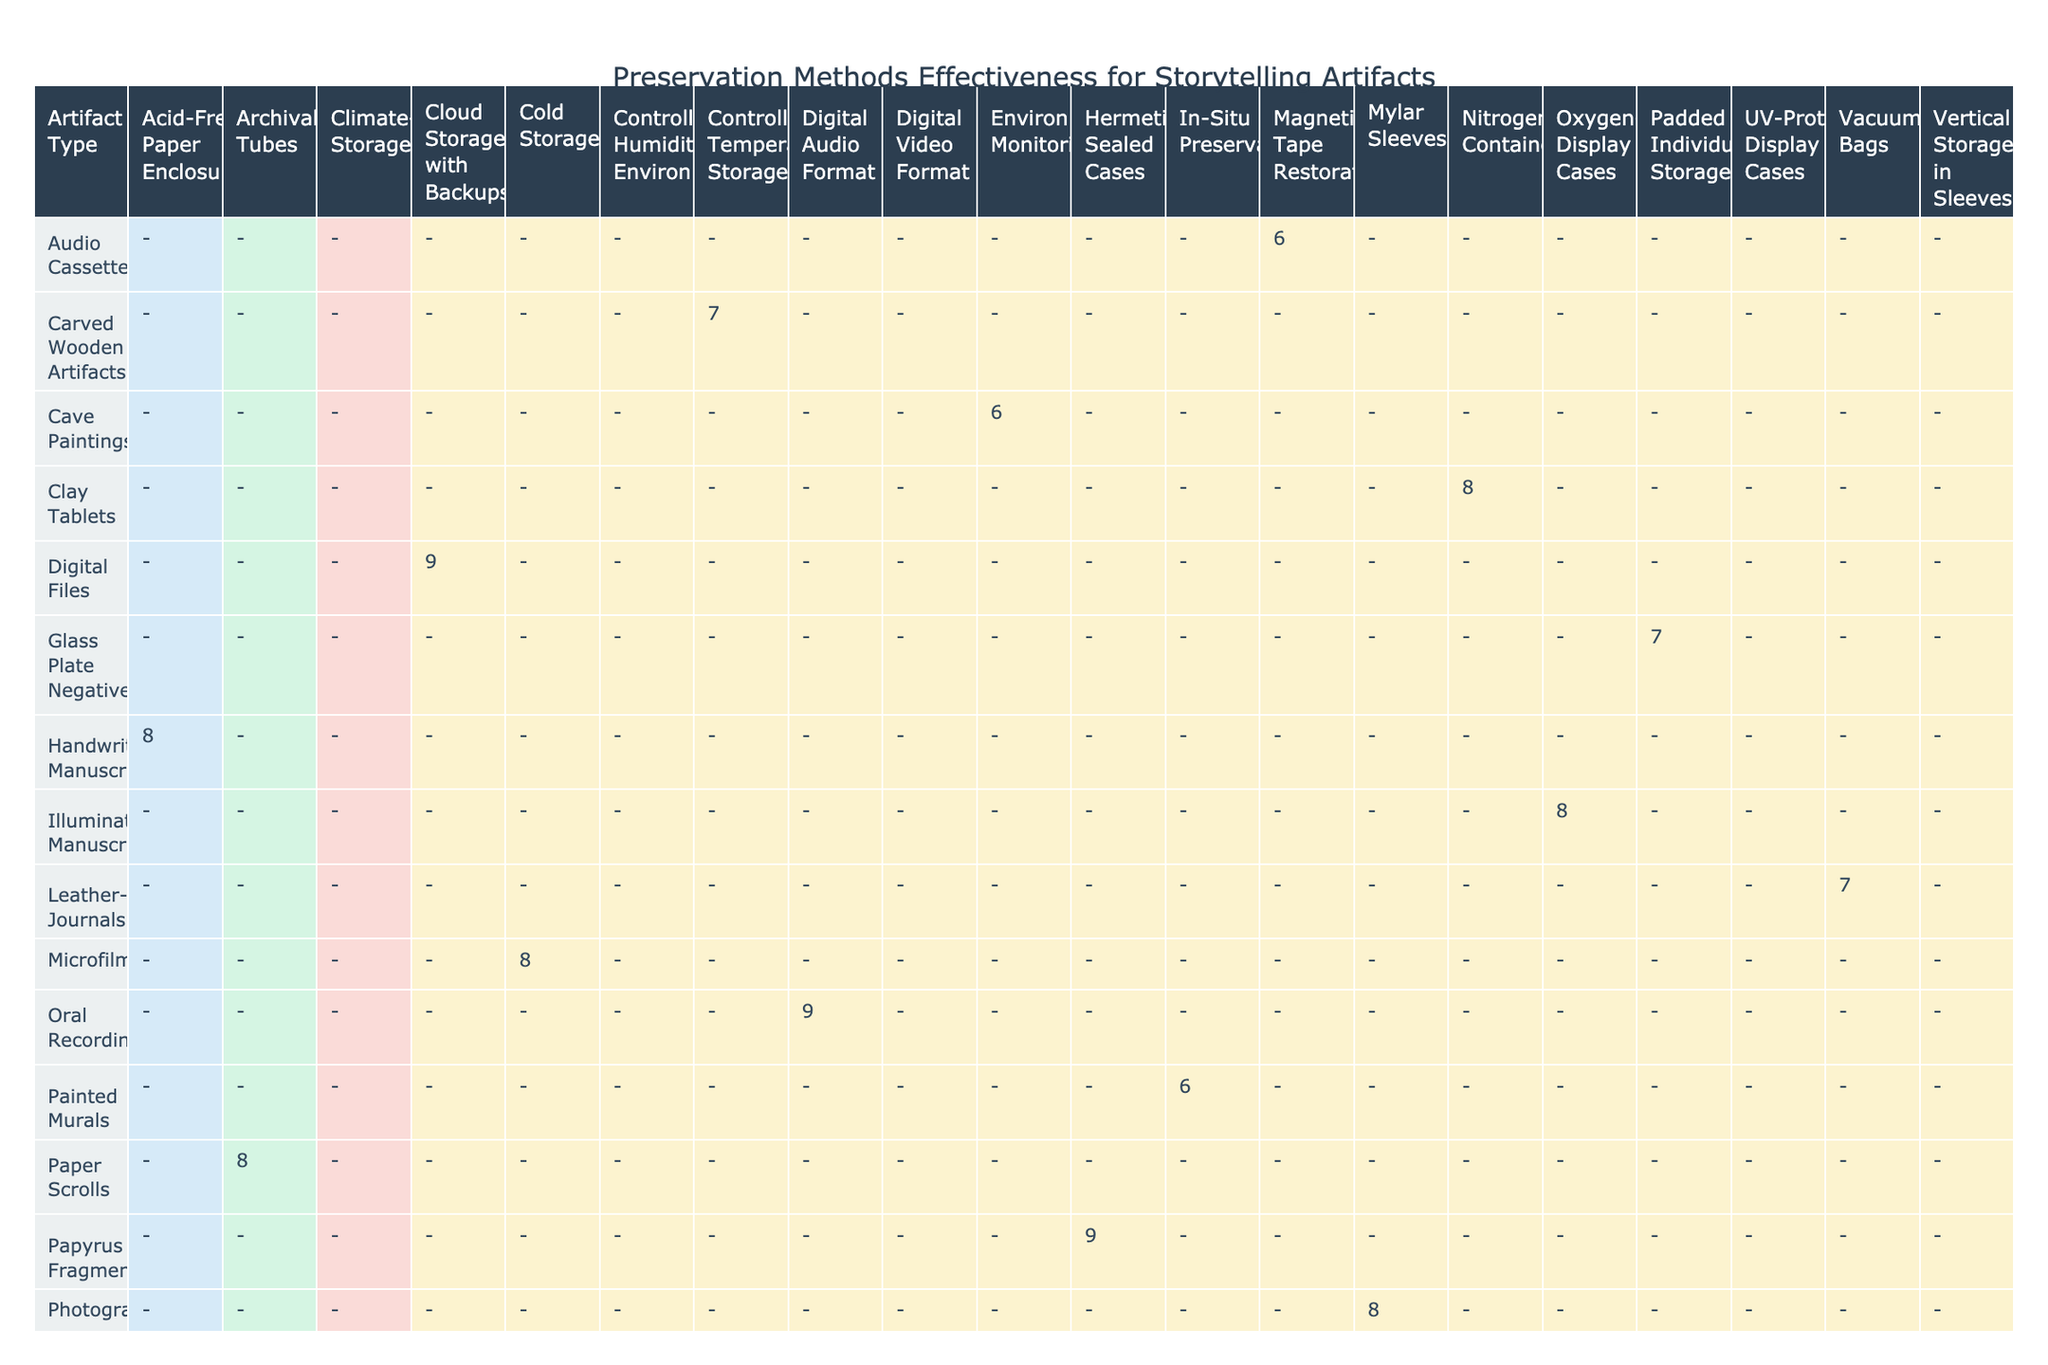What is the effectiveness rating for digital audio format preservation method? The table shows that the effectiveness rating for the digital audio format preservation method is 9.
Answer: 9 Which artifact type has the highest effectiveness rating and what is that rating? By examining the effectiveness ratings, the highest rating is 9 for both digital audio format and papyrus fragments.
Answer: 9 Is there any artifact type with a preservation method that requires more than 1000 m³ of storage space? The table indicates that there are no artifact types with preservation methods requiring more than 1000 m³, as the maximum listed is 1000 m³ for cave paintings.
Answer: No What is the average effectiveness rating for all preservation methods used for photographs? From the table, the effectiveness rating for photographs using the mylar sleeves method is 8. Therefore, the average is simply 8.
Answer: 8 How many artifact types have a digitization potential rated as 'High'? By reviewing the table, the artifact types with a digitization potential rated as 'High' are oral recordings, photographs, video recordings, audio cassettes, and vinyl records. This sums up to 5 artifact types.
Answer: 5 Can you identify how many preservation methods have an effectiveness rating of 6 or below? The preservation methods with effectiveness ratings of 6 or below include controlled humidity environment (for stone tablets), in-situ preservation (for painted murals), and magnetic tape restoration (for audio cassettes). This totals 3 methods.
Answer: 3 What is the total lifespan in years for artifact types that use the vacuum-sealed bags preservation method? The vacuum-sealed bags method is applied only to leather-bound journals, with a lifespan of 100 years. Therefore, the total lifespan related to this method is also 100 years.
Answer: 100 Which preservation method has the lowest cultural significance rating and what is that rating? Analyzing the cultural significance ratings, cold storage for microfilm has the lowest rating, which is categorized as 'Low'.
Answer: Low How does the effectiveness rating of cloud storage with backups compare with the climate-controlled storage method? The effectiveness rating for cloud storage with backups is 9, while climate-controlled storage has a rating of 7. Therefore, cloud storage is more effective than climate-controlled storage by a margin of 2.
Answer: 2 